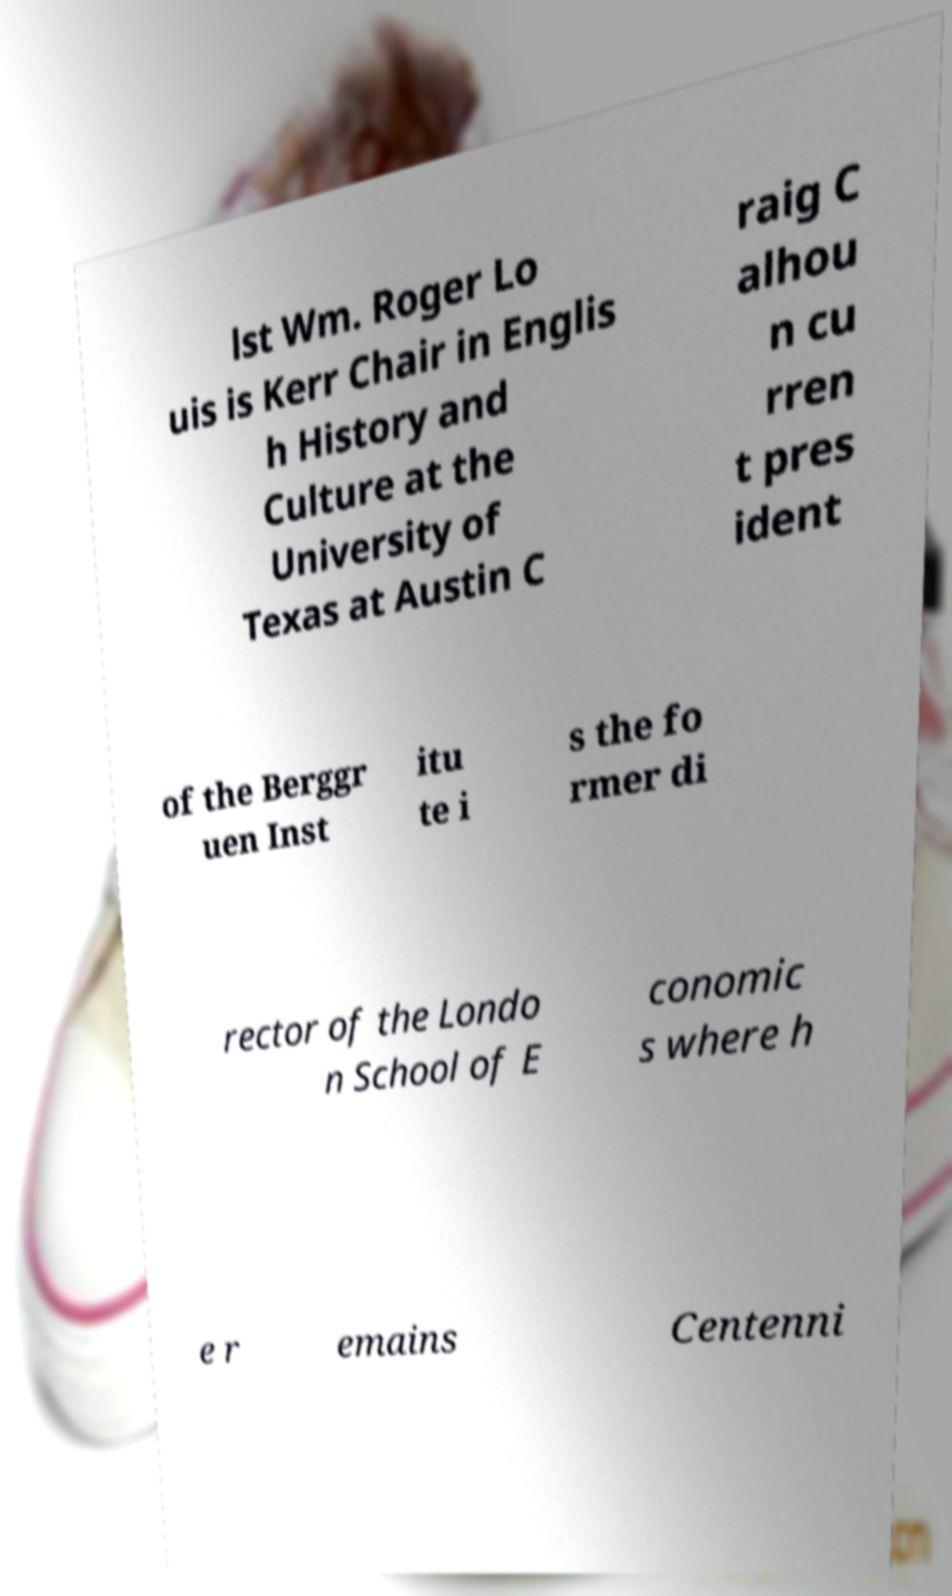What messages or text are displayed in this image? I need them in a readable, typed format. lst Wm. Roger Lo uis is Kerr Chair in Englis h History and Culture at the University of Texas at Austin C raig C alhou n cu rren t pres ident of the Berggr uen Inst itu te i s the fo rmer di rector of the Londo n School of E conomic s where h e r emains Centenni 